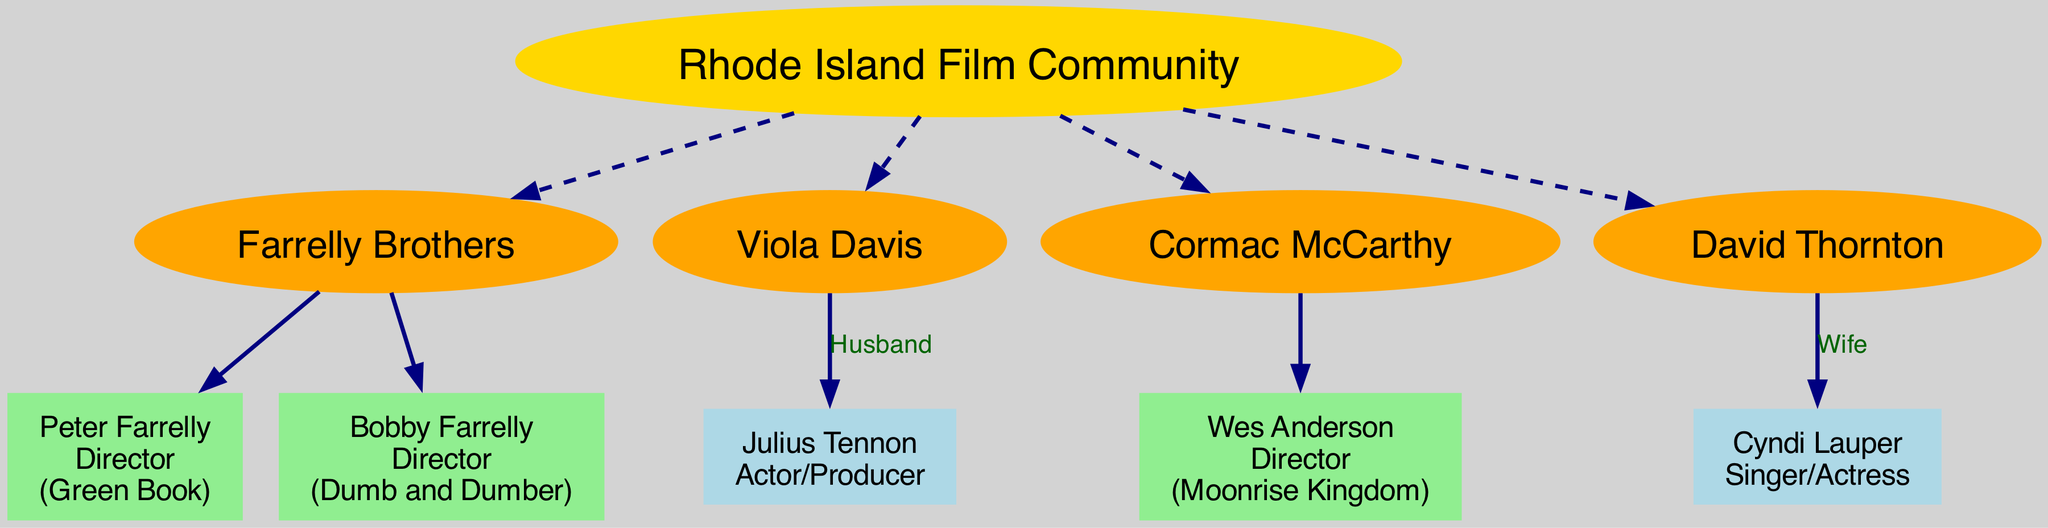What is the notable work of Peter Farrelly? The diagram shows that Peter Farrelly's notable work is "Green Book," which is listed next to his name.
Answer: Green Book How many children does Viola Davis have? The diagram indicates that Viola Davis has one child, Julius Tennon, as he is the only child listed under her.
Answer: 1 Who is Cyndi Lauper's husband? According to the diagram, Cyndi Lauper is listed as the wife of David Thornton, which establishes their relationship.
Answer: David Thornton Which filmmaker is connected to "Moonrise Kingdom"? The diagram explicitly states that Wes Anderson directed "Moonrise Kingdom," making him the filmmaker associated with that work.
Answer: Wes Anderson List the roles of the Farrelly Brothers. The diagram shows both Peter Farrelly and Bobby Farrelly listed as directors, indicating their respective roles within the family tree.
Answer: Directors How many directors are mentioned in the diagram? Upon examining the diagram, Peter Farrelly, Bobby Farrelly, and Wes Anderson are all identified as directors, totaling three.
Answer: 3 What is the notable work of Viola Davis? The diagram specifies that Viola Davis’s notable work is "Fences," which is presented alongside her name.
Answer: Fences Which branch is related to a writer? The diagram identifies Cormac McCarthy as a writer, with a direct connection to his notable work "The Road," therefore indicating the corresponding branch.
Answer: Cormac McCarthy Who directed "Dumb and Dumber"? The diagram lists Bobby Farrelly as the director of "Dumb and Dumber," which can be found next to his name in the visual representation.
Answer: Bobby Farrelly 